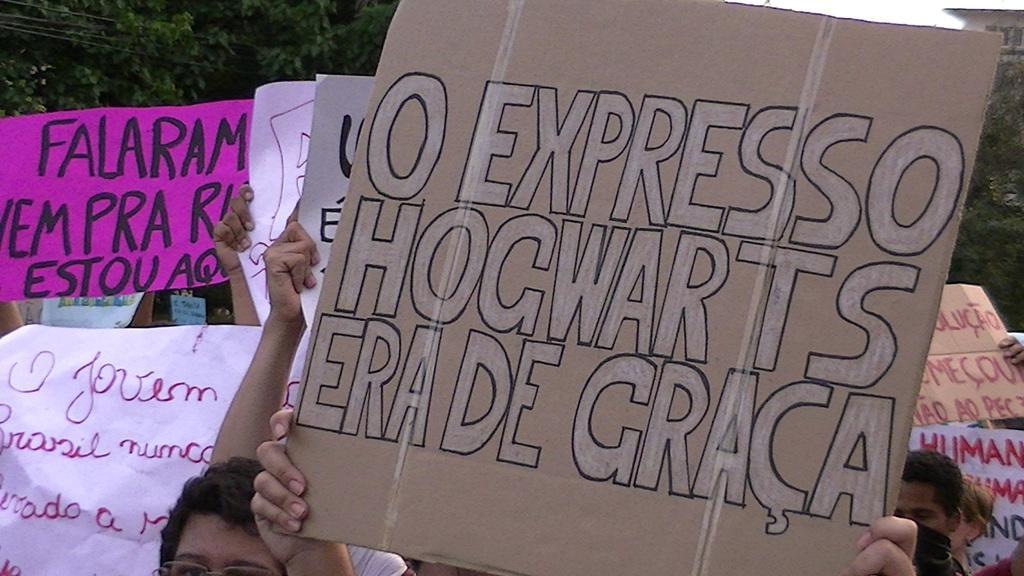Describe this image in one or two sentences. Here I can see few people are holding boards and banners in their hands. On these I can see the text. In the background there are many trees. 